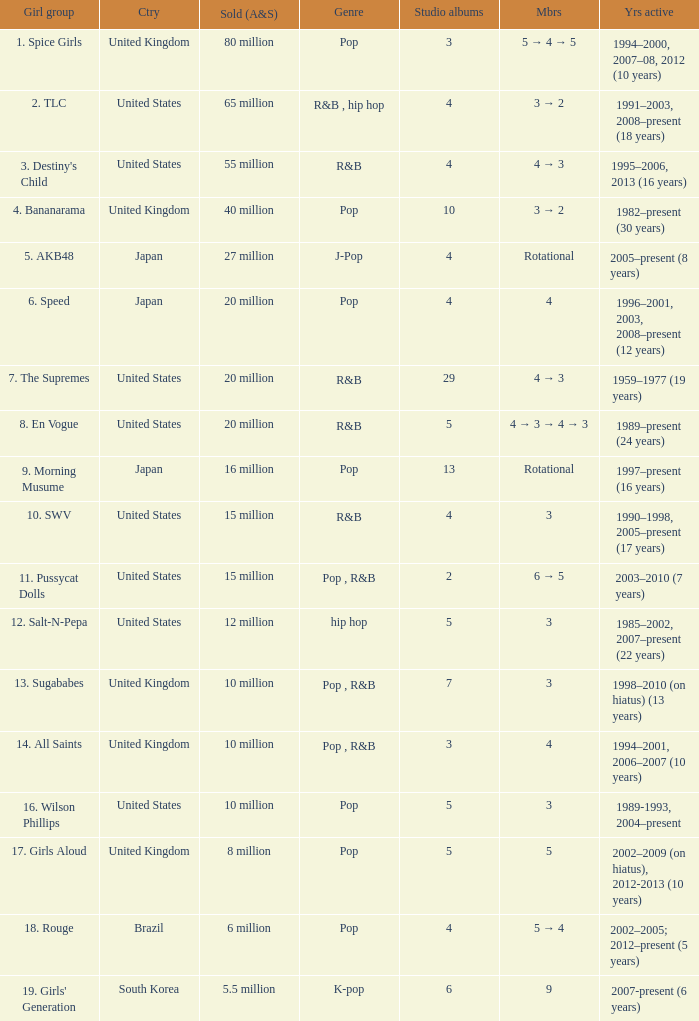What group had 29 studio albums? 7. The Supremes. 